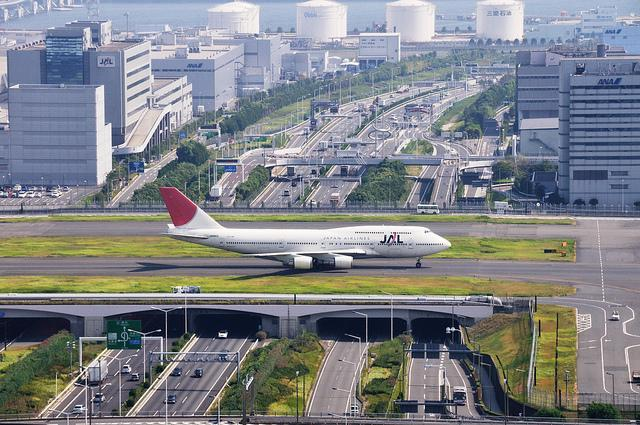What vehicle is the largest shown? Please explain your reasoning. airplane. The plane is the largest object. 